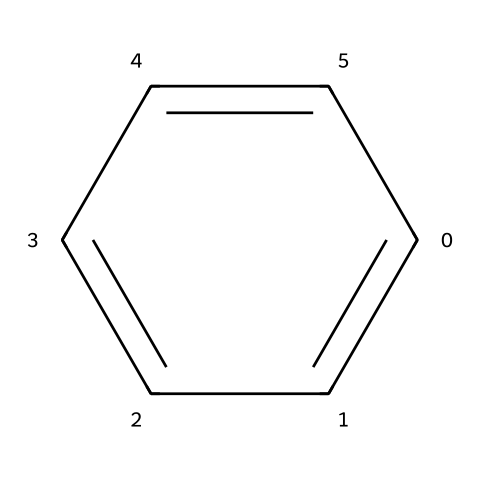What is the name of the chemical represented by this SMILES? The SMILES 'c1ccccc1' corresponds to benzene, which is indicated by its alternating double bonds between carbon atoms.
Answer: benzene How many carbon atoms are in the structure? The structure of the chemical includes six carbon atoms, as represented by the six 'c' in the SMILES.
Answer: 6 What is the degree of symmetry in the benzene molecule? Benzene exhibits D6h symmetry, meaning it has six-fold rotational symmetry and multiple reflective symmetry planes.
Answer: D6h How many hydrogen atoms are bonded to the structure? Each carbon atom in benzene is bonded to one hydrogen atom, resulting in a total of six hydrogen atoms for the six carbon atoms.
Answer: 6 What type of bonds connect the carbon atoms in benzene? The carbon atoms in benzene are connected by alternating single and double bonds, which are characteristic of aromatic compounds.
Answer: alternating single and double bonds What is a primary property of benzenoid compounds like this one? Benzenoid compounds like benzene are known for their aromaticity, a property that confers stability on the ring structure due to resonance.
Answer: aromaticity What type of hydrocarbon is benzene classified as? Benzene is classified as an aromatic hydrocarbon due to the presence of delocalized electrons in its cyclic structure.
Answer: aromatic hydrocarbon 